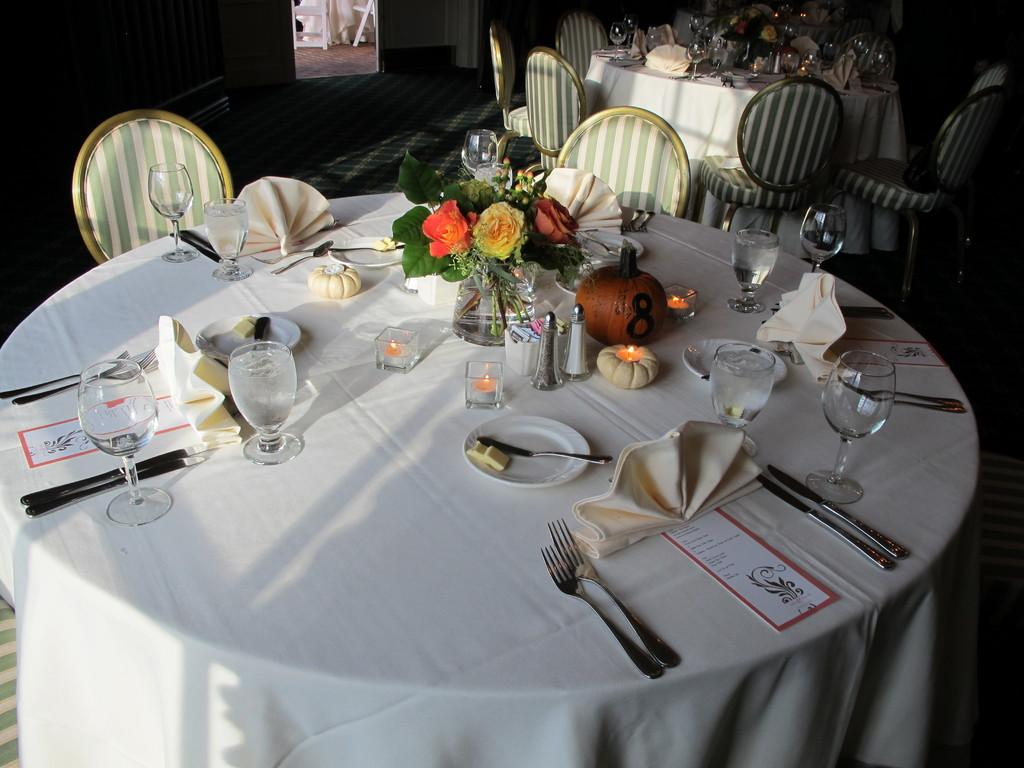What type of furniture is in the image? There is a dining table in the image. What accompanies the dining table? Chairs are present around the dining table. What decorative item can be seen on the table? There is a small plant on the table. What tableware is visible on the table? Cups, tissues, knives, forks, glasses, and salt and pepper jars are on the table. What type of scarf is draped over the salt and pepper jars in the image? There is no scarf present in the image; it only features a dining table, chairs, a small plant, cups, tissues, knives, forks, glasses, and salt and pepper jars. 